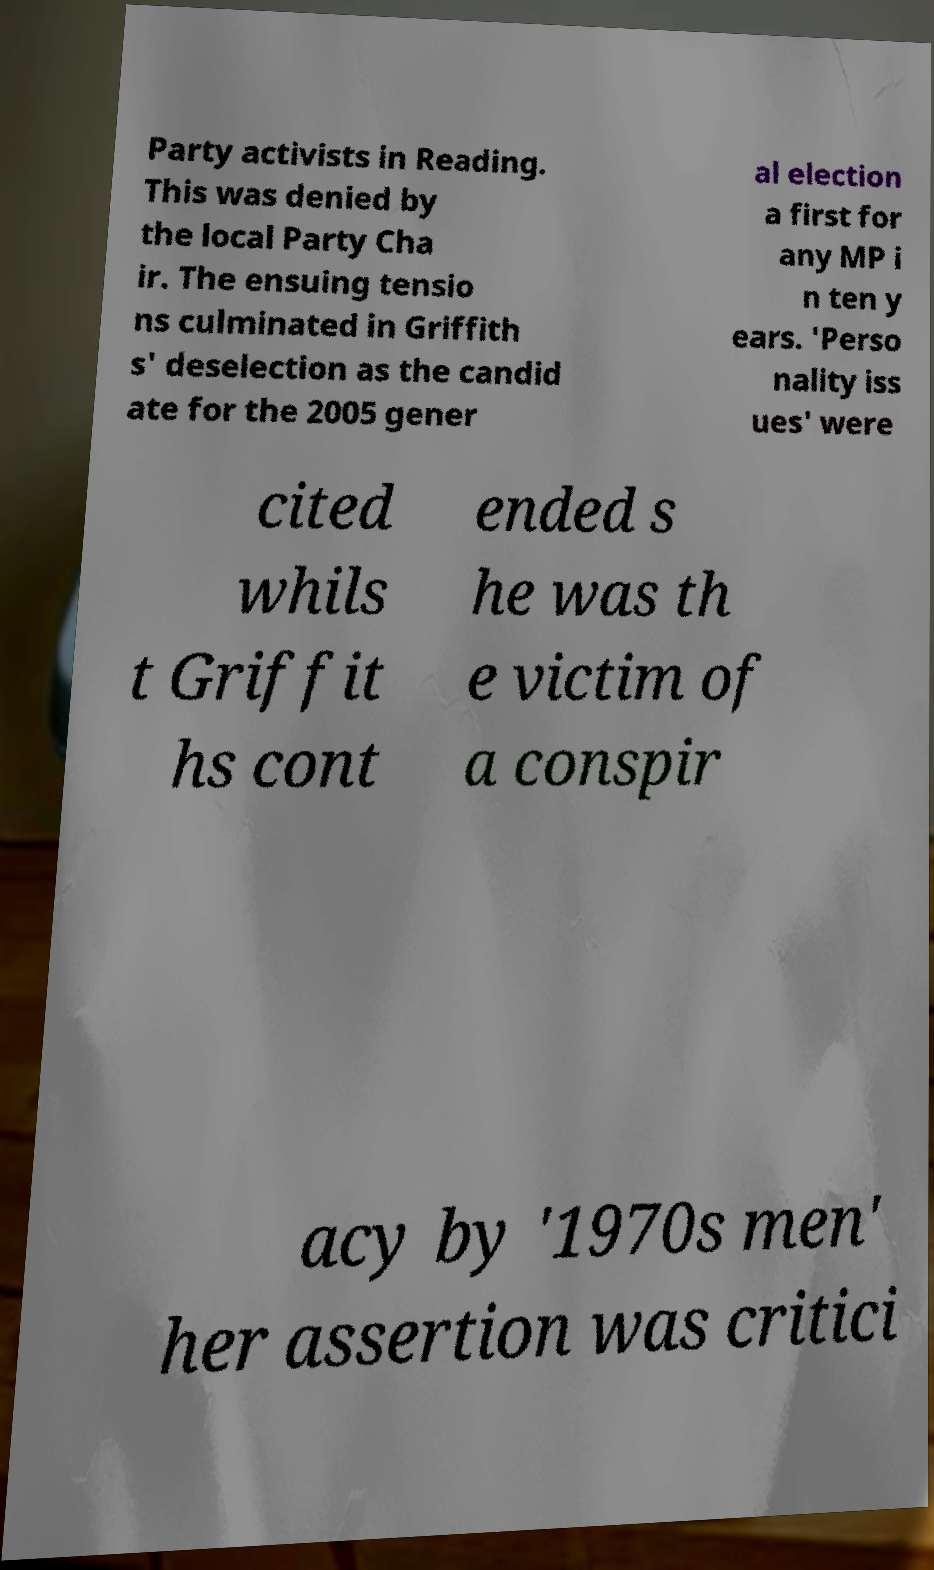Could you assist in decoding the text presented in this image and type it out clearly? Party activists in Reading. This was denied by the local Party Cha ir. The ensuing tensio ns culminated in Griffith s' deselection as the candid ate for the 2005 gener al election a first for any MP i n ten y ears. 'Perso nality iss ues' were cited whils t Griffit hs cont ended s he was th e victim of a conspir acy by '1970s men' her assertion was critici 